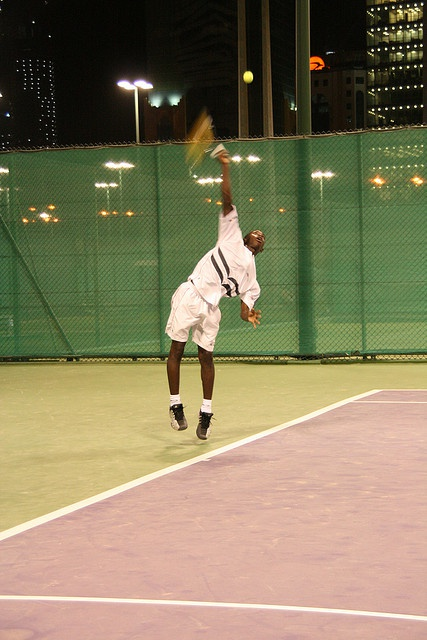Describe the objects in this image and their specific colors. I can see people in black, white, maroon, and tan tones, tennis racket in black, olive, maroon, and tan tones, and sports ball in black, khaki, olive, and gold tones in this image. 